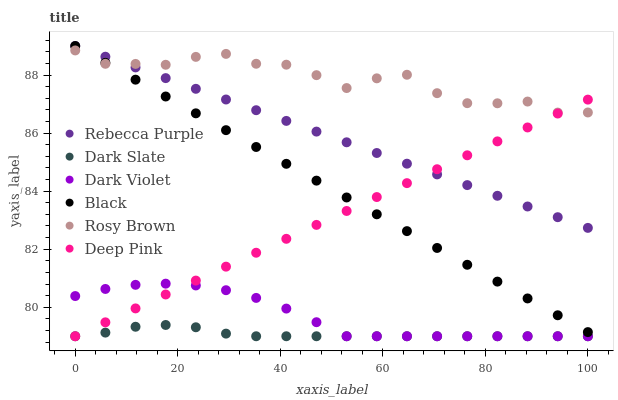Does Dark Slate have the minimum area under the curve?
Answer yes or no. Yes. Does Rosy Brown have the maximum area under the curve?
Answer yes or no. Yes. Does Dark Violet have the minimum area under the curve?
Answer yes or no. No. Does Dark Violet have the maximum area under the curve?
Answer yes or no. No. Is Rebecca Purple the smoothest?
Answer yes or no. Yes. Is Rosy Brown the roughest?
Answer yes or no. Yes. Is Dark Violet the smoothest?
Answer yes or no. No. Is Dark Violet the roughest?
Answer yes or no. No. Does Deep Pink have the lowest value?
Answer yes or no. Yes. Does Rosy Brown have the lowest value?
Answer yes or no. No. Does Rebecca Purple have the highest value?
Answer yes or no. Yes. Does Rosy Brown have the highest value?
Answer yes or no. No. Is Dark Slate less than Rebecca Purple?
Answer yes or no. Yes. Is Rosy Brown greater than Dark Slate?
Answer yes or no. Yes. Does Rosy Brown intersect Rebecca Purple?
Answer yes or no. Yes. Is Rosy Brown less than Rebecca Purple?
Answer yes or no. No. Is Rosy Brown greater than Rebecca Purple?
Answer yes or no. No. Does Dark Slate intersect Rebecca Purple?
Answer yes or no. No. 